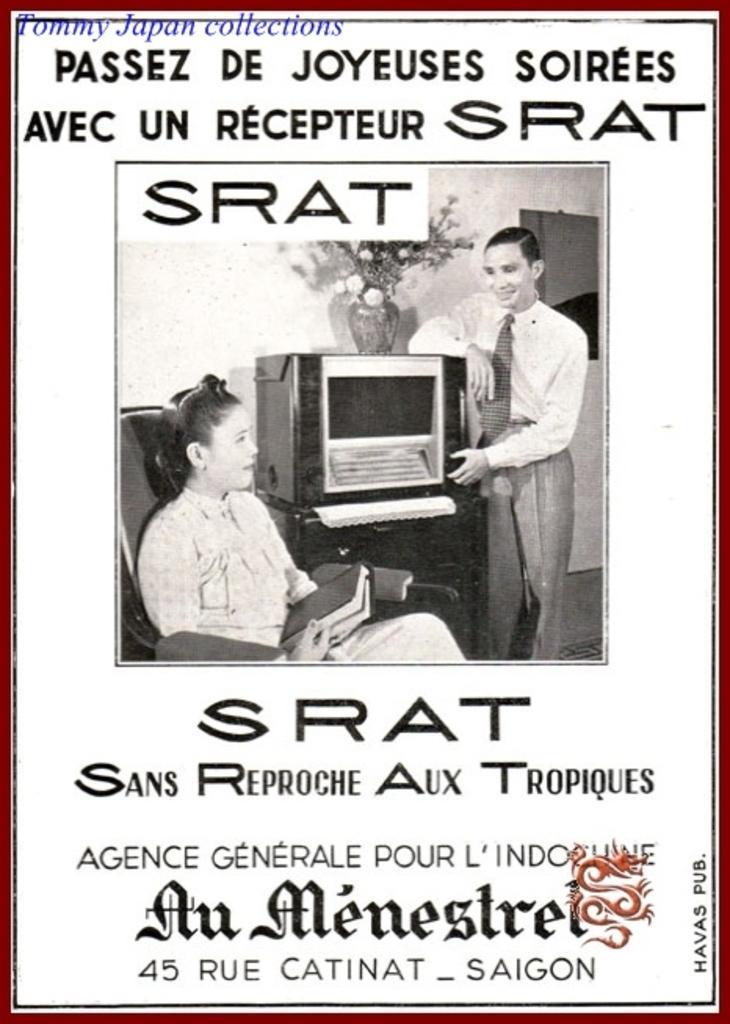Please provide a concise description of this image. In this image we can see the black and white picture of a woman sitting on a chair holding a book and a man standing beside a table containing a device and a flower vase on it. We can also see some text on this image. 